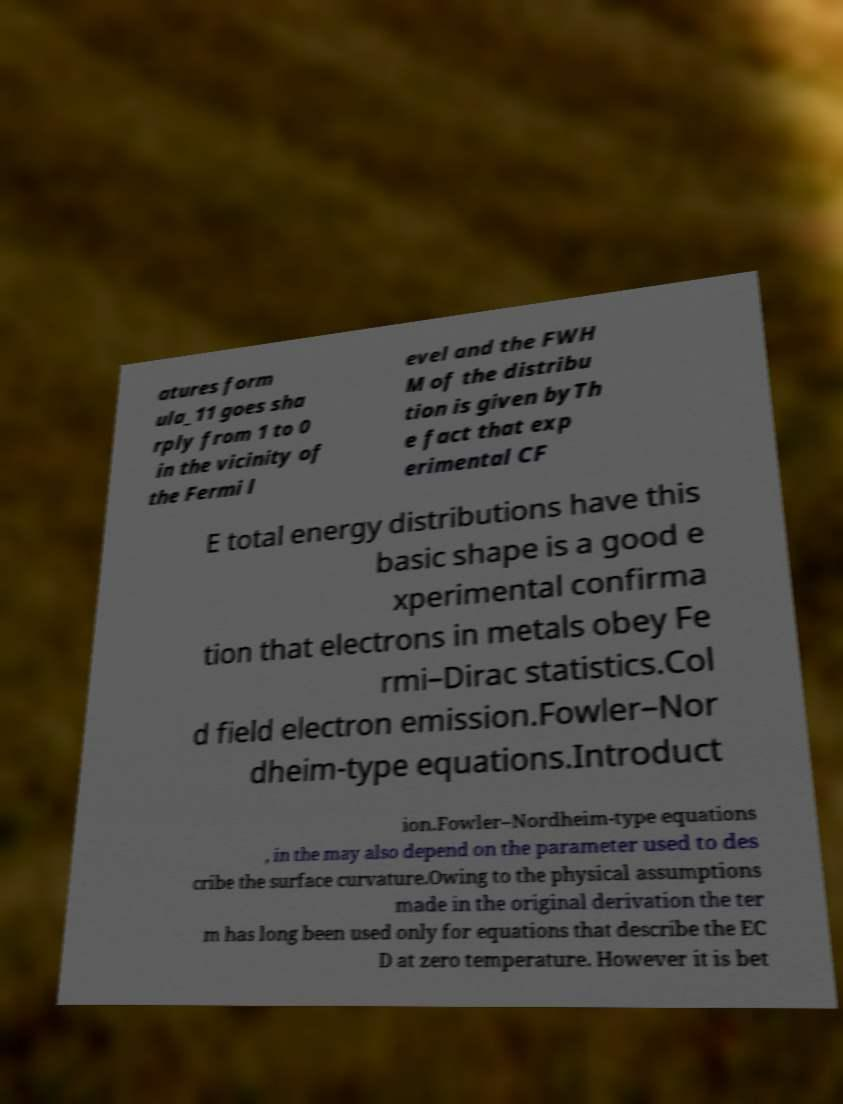I need the written content from this picture converted into text. Can you do that? atures form ula_11 goes sha rply from 1 to 0 in the vicinity of the Fermi l evel and the FWH M of the distribu tion is given byTh e fact that exp erimental CF E total energy distributions have this basic shape is a good e xperimental confirma tion that electrons in metals obey Fe rmi–Dirac statistics.Col d field electron emission.Fowler–Nor dheim-type equations.Introduct ion.Fowler–Nordheim-type equations , in the may also depend on the parameter used to des cribe the surface curvature.Owing to the physical assumptions made in the original derivation the ter m has long been used only for equations that describe the EC D at zero temperature. However it is bet 